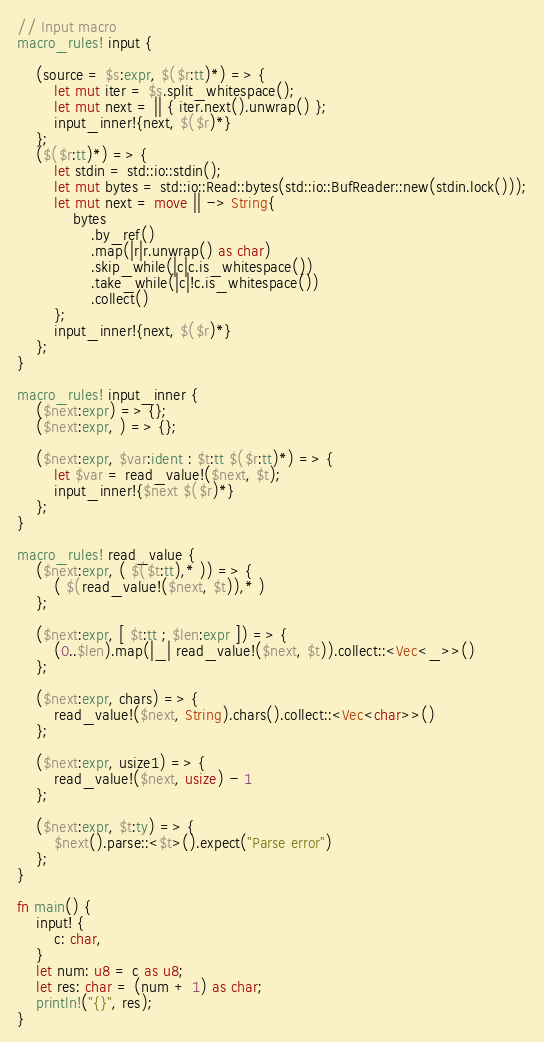Convert code to text. <code><loc_0><loc_0><loc_500><loc_500><_Rust_>// Input macro
macro_rules! input {

    (source = $s:expr, $($r:tt)*) => {
        let mut iter = $s.split_whitespace();
        let mut next = || { iter.next().unwrap() };
        input_inner!{next, $($r)*}
    };
    ($($r:tt)*) => {
        let stdin = std::io::stdin();
        let mut bytes = std::io::Read::bytes(std::io::BufReader::new(stdin.lock()));
        let mut next = move || -> String{
            bytes
                .by_ref()
                .map(|r|r.unwrap() as char)
                .skip_while(|c|c.is_whitespace())
                .take_while(|c|!c.is_whitespace())
                .collect()
        };
        input_inner!{next, $($r)*}
    };
}

macro_rules! input_inner {
    ($next:expr) => {};
    ($next:expr, ) => {};

    ($next:expr, $var:ident : $t:tt $($r:tt)*) => {
        let $var = read_value!($next, $t);
        input_inner!{$next $($r)*}
    };
}

macro_rules! read_value {
    ($next:expr, ( $($t:tt),* )) => {
        ( $(read_value!($next, $t)),* )
    };

    ($next:expr, [ $t:tt ; $len:expr ]) => {
        (0..$len).map(|_| read_value!($next, $t)).collect::<Vec<_>>()
    };

    ($next:expr, chars) => {
        read_value!($next, String).chars().collect::<Vec<char>>()
    };

    ($next:expr, usize1) => {
        read_value!($next, usize) - 1
    };

    ($next:expr, $t:ty) => {
        $next().parse::<$t>().expect("Parse error")
    };
}

fn main() {
    input! {
        c: char,
    }
    let num: u8 = c as u8;
    let res: char = (num + 1) as char;
    println!("{}", res);
}
</code> 